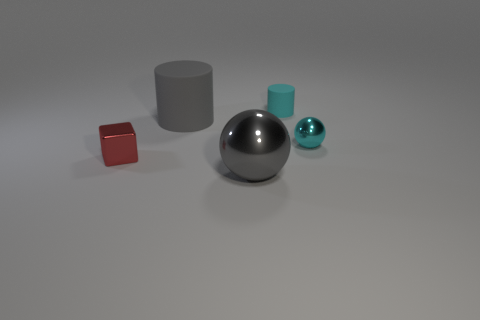Add 4 small green rubber balls. How many objects exist? 9 Subtract all blocks. How many objects are left? 4 Add 1 big purple things. How many big purple things exist? 1 Subtract 1 gray balls. How many objects are left? 4 Subtract all tiny cyan cylinders. Subtract all large gray matte objects. How many objects are left? 3 Add 4 small metallic things. How many small metallic things are left? 6 